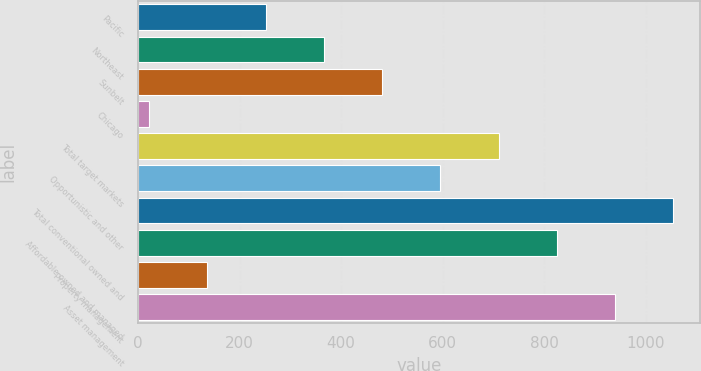Convert chart. <chart><loc_0><loc_0><loc_500><loc_500><bar_chart><fcel>Pacific<fcel>Northeast<fcel>Sunbelt<fcel>Chicago<fcel>Total target markets<fcel>Opportunistic and other<fcel>Total conventional owned and<fcel>Affordable owned and managed<fcel>Property management<fcel>Asset management<nl><fcel>251.4<fcel>366.1<fcel>480.8<fcel>22<fcel>710.2<fcel>595.5<fcel>1054.3<fcel>824.9<fcel>136.7<fcel>939.6<nl></chart> 